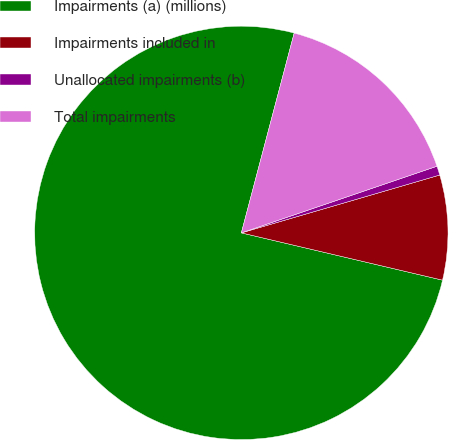Convert chart. <chart><loc_0><loc_0><loc_500><loc_500><pie_chart><fcel>Impairments (a) (millions)<fcel>Impairments included in<fcel>Unallocated impairments (b)<fcel>Total impairments<nl><fcel>75.44%<fcel>8.19%<fcel>0.71%<fcel>15.66%<nl></chart> 